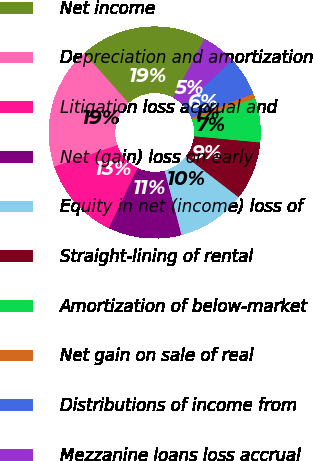Convert chart to OTSL. <chart><loc_0><loc_0><loc_500><loc_500><pie_chart><fcel>Net income<fcel>Depreciation and amortization<fcel>Litigation loss accrual and<fcel>Net (gain) loss on early<fcel>Equity in net (income) loss of<fcel>Straight-lining of rental<fcel>Amortization of below-market<fcel>Net gain on sale of real<fcel>Distributions of income from<fcel>Mezzanine loans loss accrual<nl><fcel>19.38%<fcel>18.64%<fcel>12.68%<fcel>11.19%<fcel>10.45%<fcel>8.96%<fcel>6.72%<fcel>0.76%<fcel>5.98%<fcel>5.23%<nl></chart> 